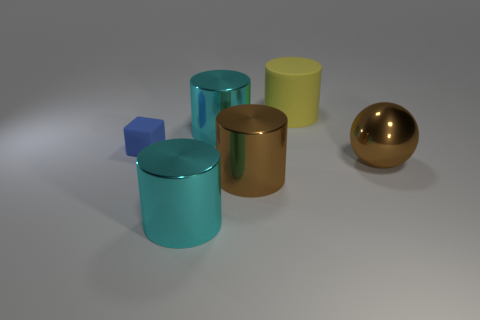Are there any other things that have the same size as the blue block?
Provide a short and direct response. No. The blue cube is what size?
Provide a short and direct response. Small. What is the large yellow thing made of?
Your answer should be very brief. Rubber. Do the rubber object in front of the rubber cylinder and the big brown shiny cylinder have the same size?
Offer a terse response. No. What number of objects are cyan shiny cylinders or small matte cubes?
Provide a succinct answer. 3. How big is the cylinder that is to the left of the big yellow object and behind the large brown sphere?
Your response must be concise. Large. What number of blue rubber balls are there?
Offer a terse response. 0. What number of cylinders are big cyan metal things or big yellow rubber objects?
Keep it short and to the point. 3. There is a cyan shiny cylinder to the left of the cyan cylinder that is behind the large brown sphere; what number of big shiny things are behind it?
Provide a short and direct response. 3. There is a matte cylinder that is the same size as the metal sphere; what is its color?
Keep it short and to the point. Yellow. 